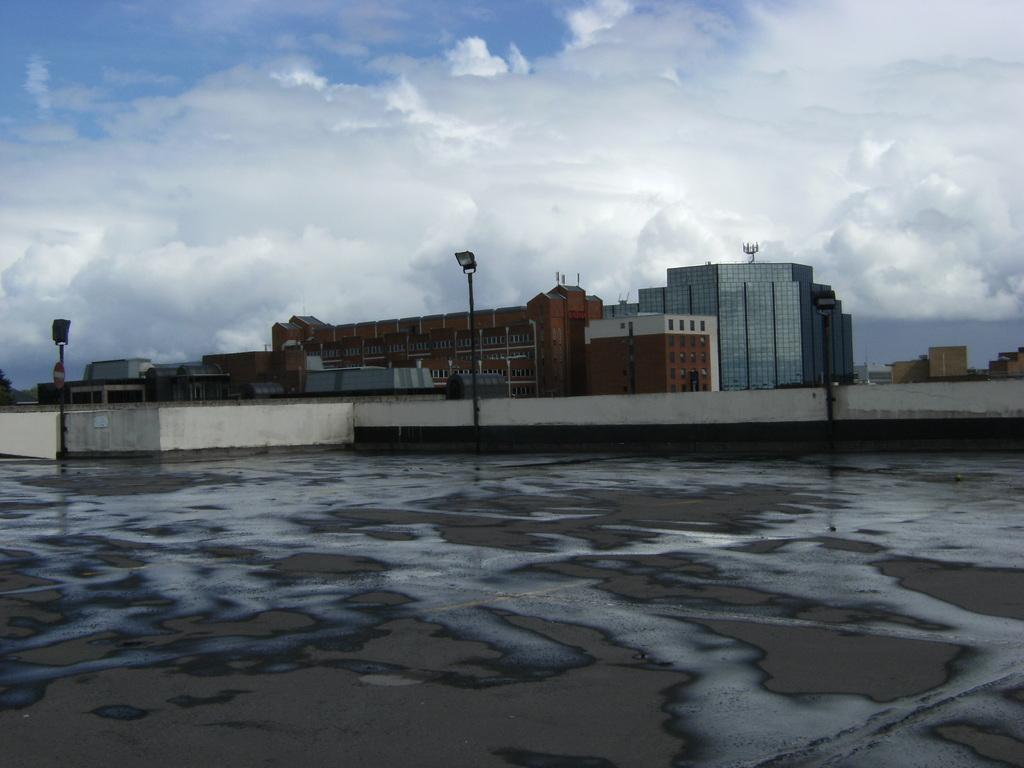What type of structures can be seen in the image? There are buildings in the image. What else can be seen in the image besides the buildings? There are poles and a wall visible in the image. What is visible in the background of the image? The sky is visible in the image, and clouds are present in the sky. How many bears are sitting on the wall in the image? There are no bears present in the image; it only features buildings, poles, a wall, and the sky with clouds. 